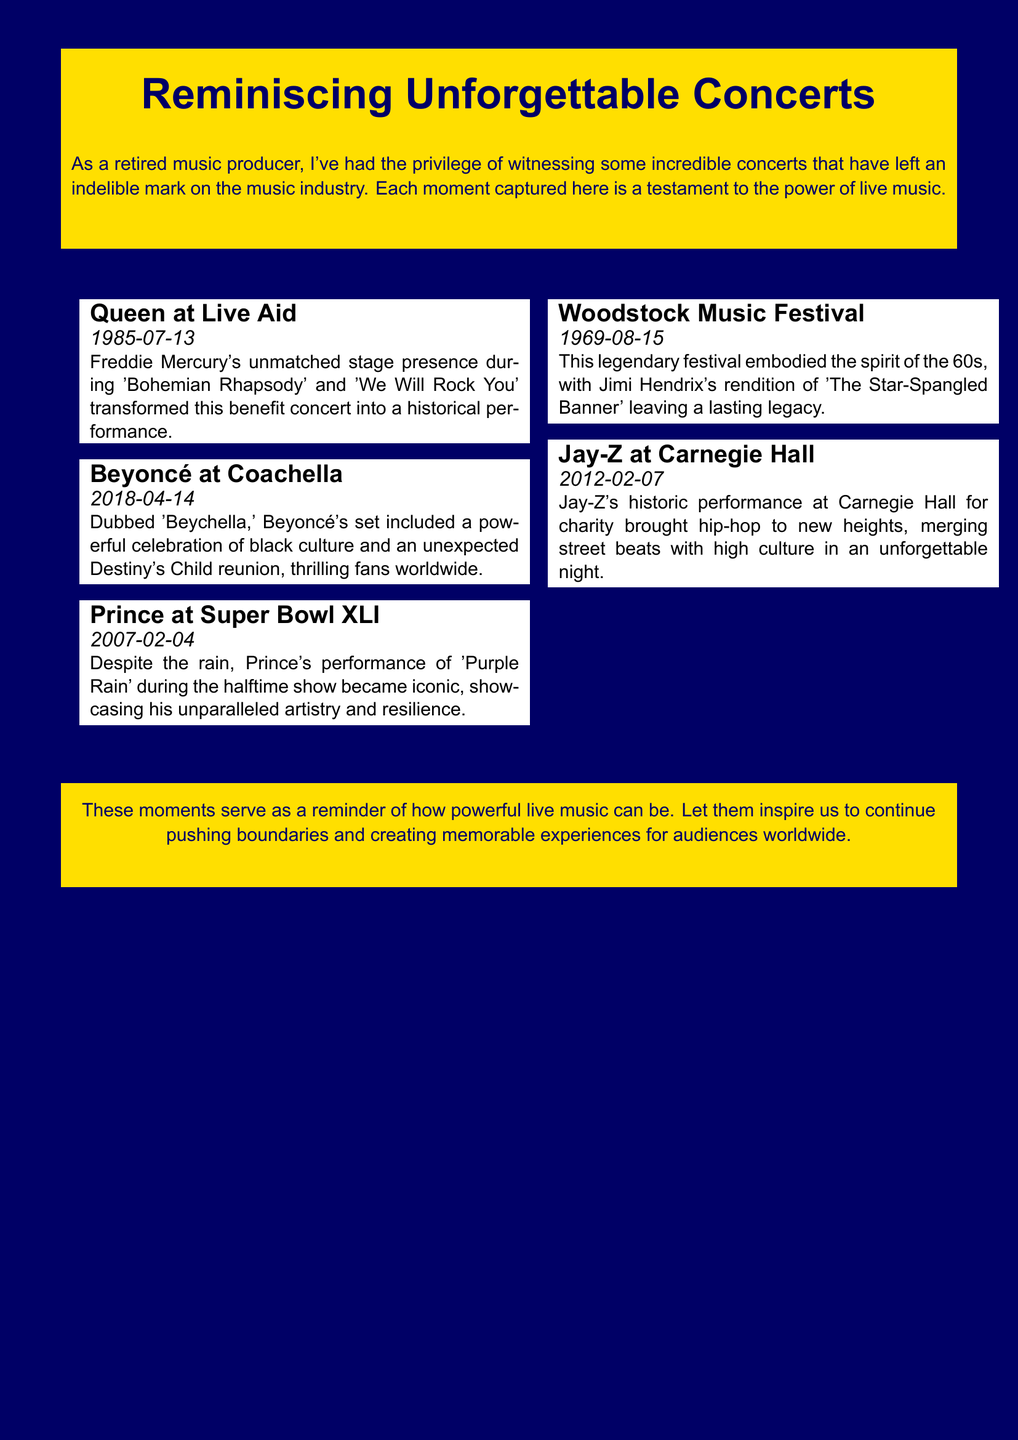What concert took place on July 13, 1985? The concert mentioned is Queen's performance at Live Aid, which is specifically noted in the document.
Answer: Queen at Live Aid Who performed at Coachella in 2018? The document lists Beyoncé as the performer at Coachella, specifically mentioning the date and the event name.
Answer: Beyoncé What was Prince's iconic song performed at Super Bowl XLI? The document cites 'Purple Rain' as the song performed by Prince during the Super Bowl halftime show.
Answer: Purple Rain Which festival featured Jimi Hendrix in 1969? The document notes the Woodstock Music Festival as the event that highlighted Jimi Hendrix's performance.
Answer: Woodstock Music Festival What did Jay-Z merge in his Carnegie Hall performance? According to the document, Jay-Z's performance merged street beats with high culture, emphasizing the combination in his historic concert.
Answer: Street beats and high culture How many concerts are highlighted in the document? The document outlines five notable concerts, each with brief descriptions of their significance.
Answer: Five What memorable moment is associated with the phrase "Beychella"? The term refers to Beyoncé's celebrated performance at Coachella, as highlighted in the document.
Answer: Beyoncé at Coachella What was a key feature of the Woodstock Music Festival? The document mentions Jimi Hendrix's rendition of 'The Star-Spangled Banner' as a significant and memorable moment from the festival.
Answer: Jimi Hendrix's rendition What type of events are discussed in the document? The document focuses on memorable concert performances and moments in music history.
Answer: Concert performances 